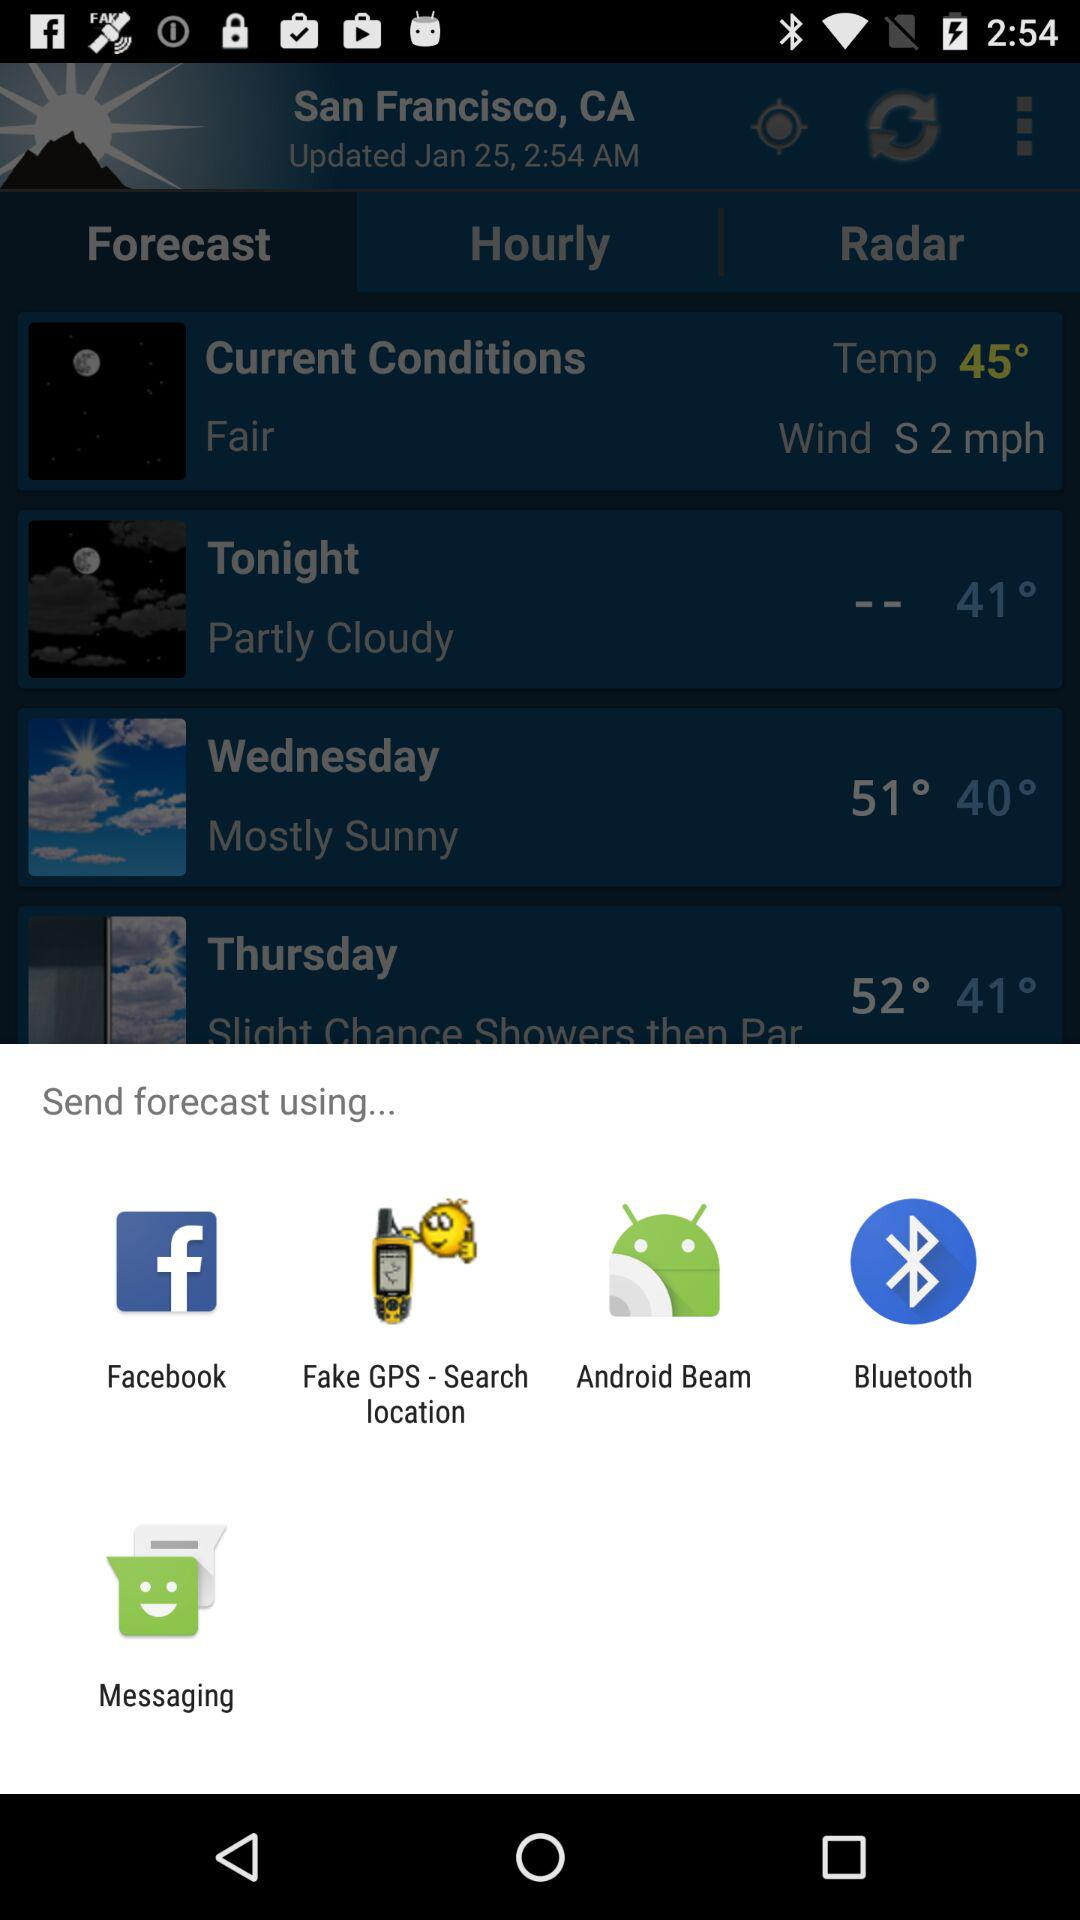What is the given location? The given location is San Francisco, CA. 